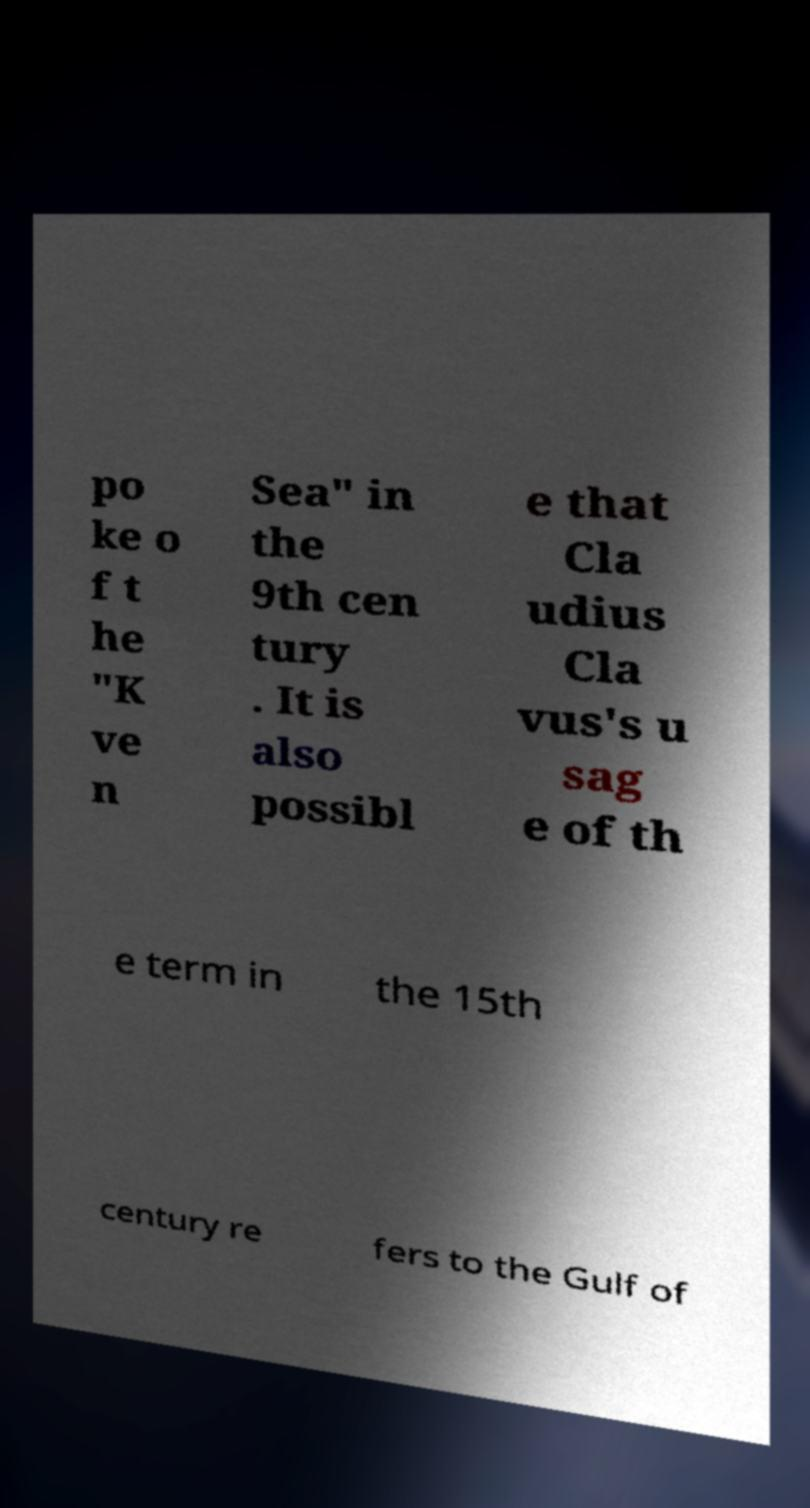Please identify and transcribe the text found in this image. po ke o f t he "K ve n Sea" in the 9th cen tury . It is also possibl e that Cla udius Cla vus's u sag e of th e term in the 15th century re fers to the Gulf of 